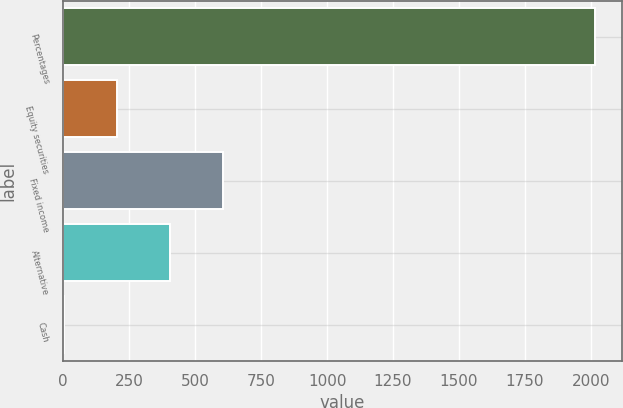<chart> <loc_0><loc_0><loc_500><loc_500><bar_chart><fcel>Percentages<fcel>Equity securities<fcel>Fixed income<fcel>Alternative<fcel>Cash<nl><fcel>2016<fcel>203.4<fcel>606.2<fcel>404.8<fcel>2<nl></chart> 